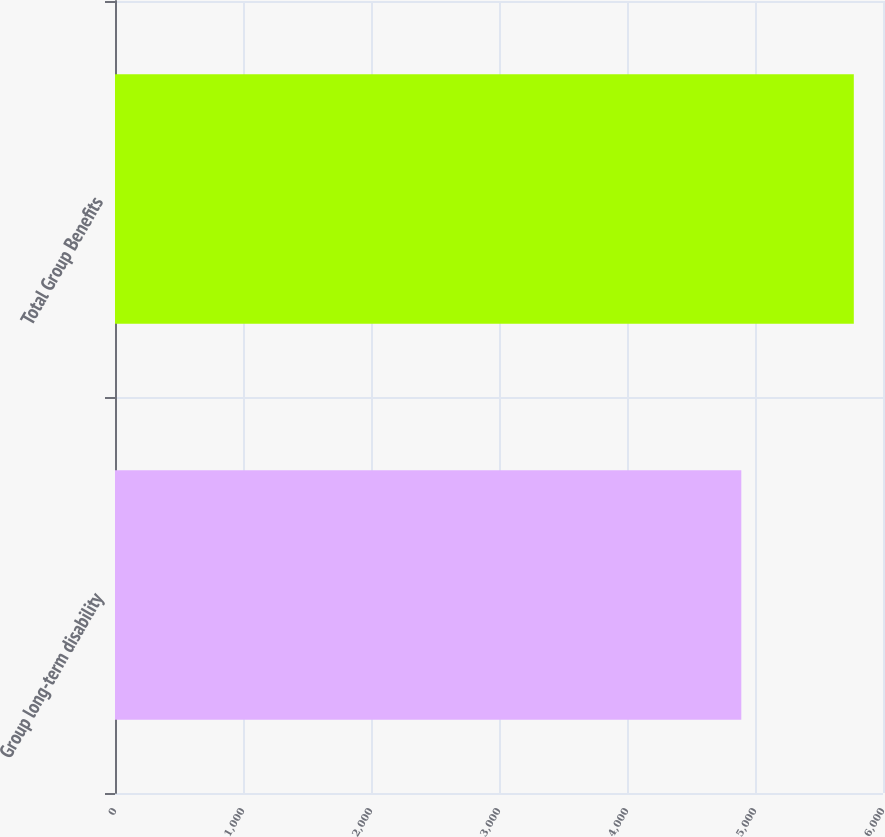Convert chart. <chart><loc_0><loc_0><loc_500><loc_500><bar_chart><fcel>Group long-term disability<fcel>Total Group Benefits<nl><fcel>4893<fcel>5772<nl></chart> 